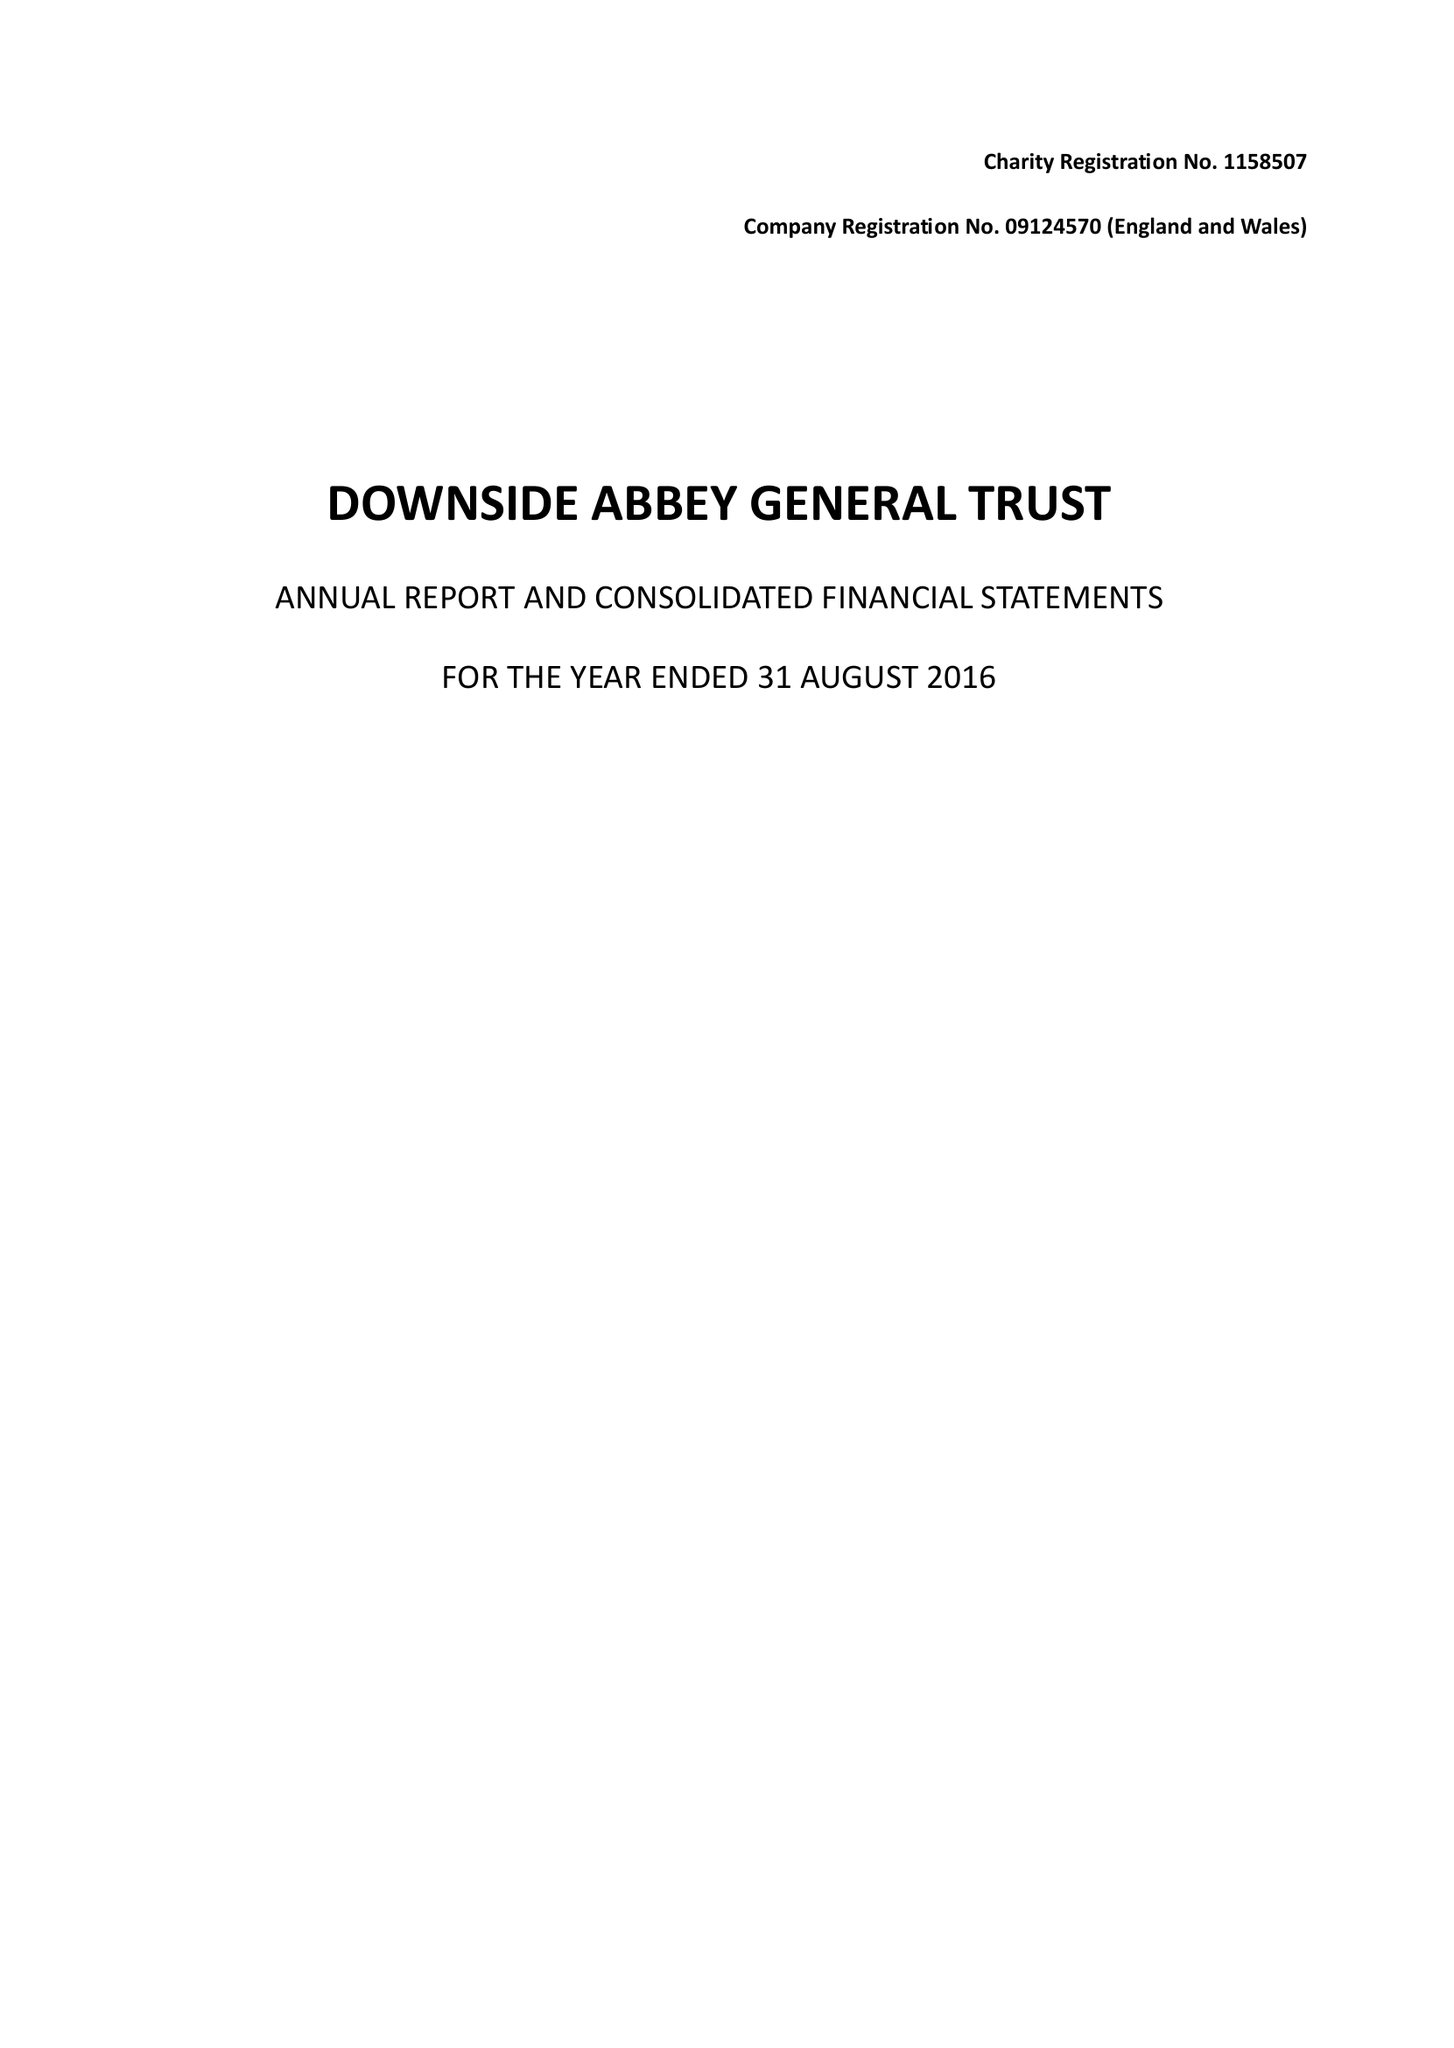What is the value for the address__post_town?
Answer the question using a single word or phrase. RADSTOCK 